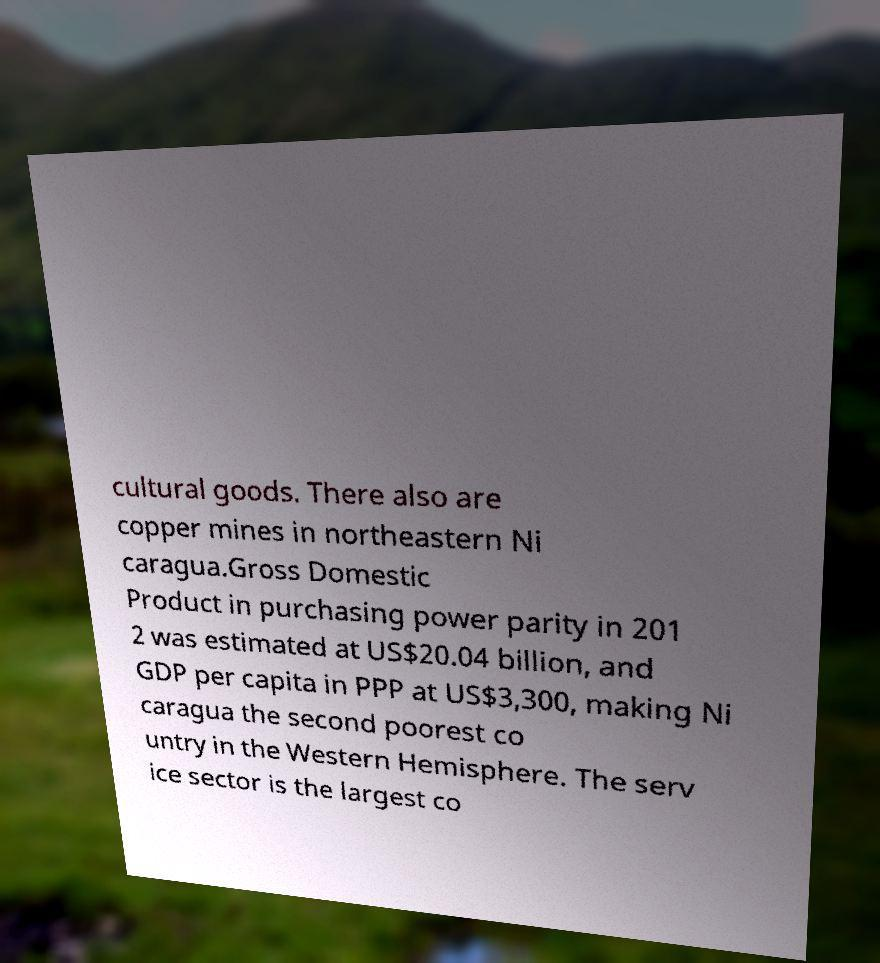Can you accurately transcribe the text from the provided image for me? cultural goods. There also are copper mines in northeastern Ni caragua.Gross Domestic Product in purchasing power parity in 201 2 was estimated at US$20.04 billion, and GDP per capita in PPP at US$3,300, making Ni caragua the second poorest co untry in the Western Hemisphere. The serv ice sector is the largest co 